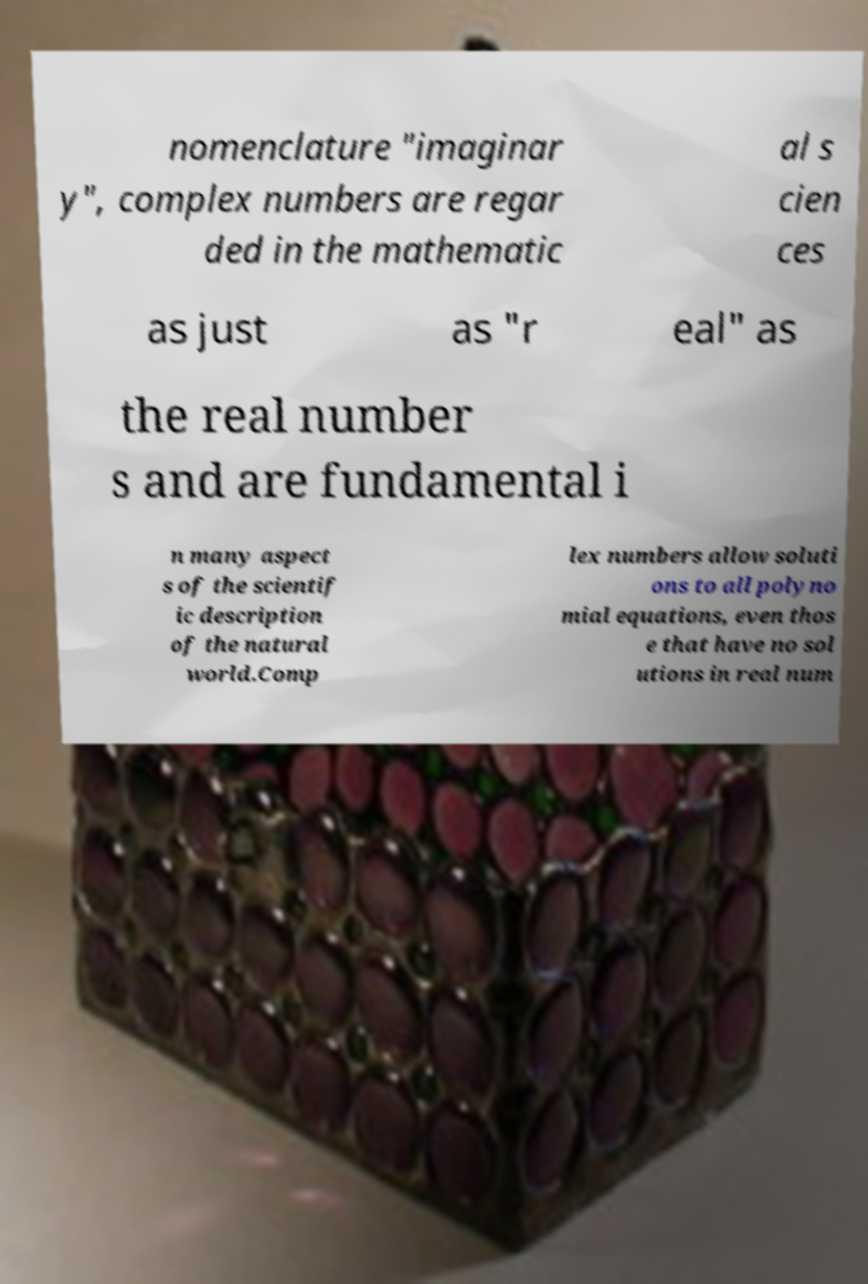For documentation purposes, I need the text within this image transcribed. Could you provide that? nomenclature "imaginar y", complex numbers are regar ded in the mathematic al s cien ces as just as "r eal" as the real number s and are fundamental i n many aspect s of the scientif ic description of the natural world.Comp lex numbers allow soluti ons to all polyno mial equations, even thos e that have no sol utions in real num 